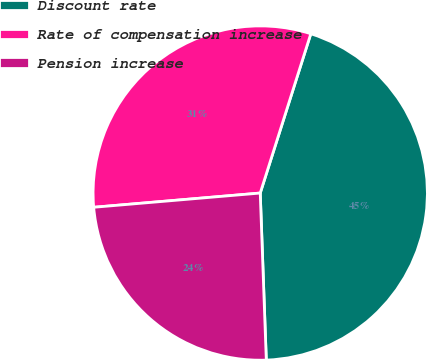<chart> <loc_0><loc_0><loc_500><loc_500><pie_chart><fcel>Discount rate<fcel>Rate of compensation increase<fcel>Pension increase<nl><fcel>44.53%<fcel>31.25%<fcel>24.22%<nl></chart> 